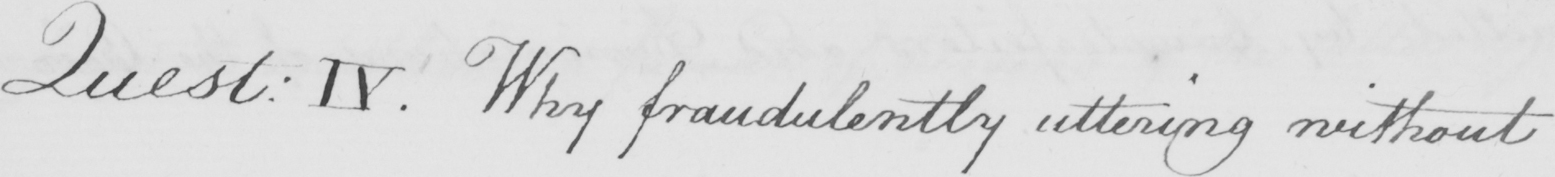Please provide the text content of this handwritten line. Quest :  IV . Why fraudulently uttering without 